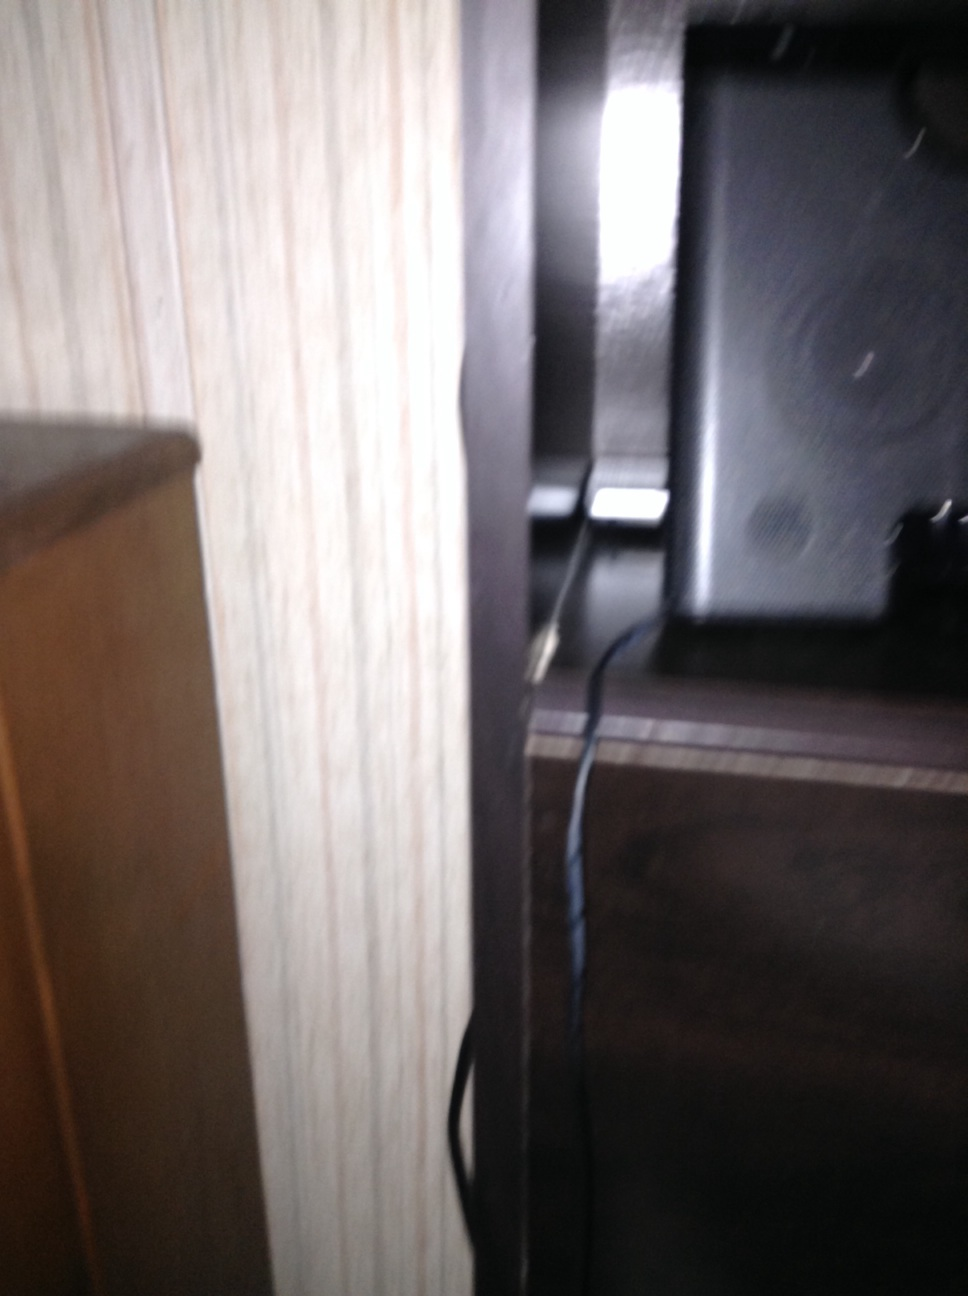What if this speaker could talk? What stories would it tell? If this speaker could talk, it might tell stories of countless evenings filled with music and laughter. It could recount the various genres of music it has played, from soothing jazz during quiet nights to energetic rock during lively gatherings. It might share memories of audiobooks it has narrated, and the emotional reactions they invoked in listeners. 